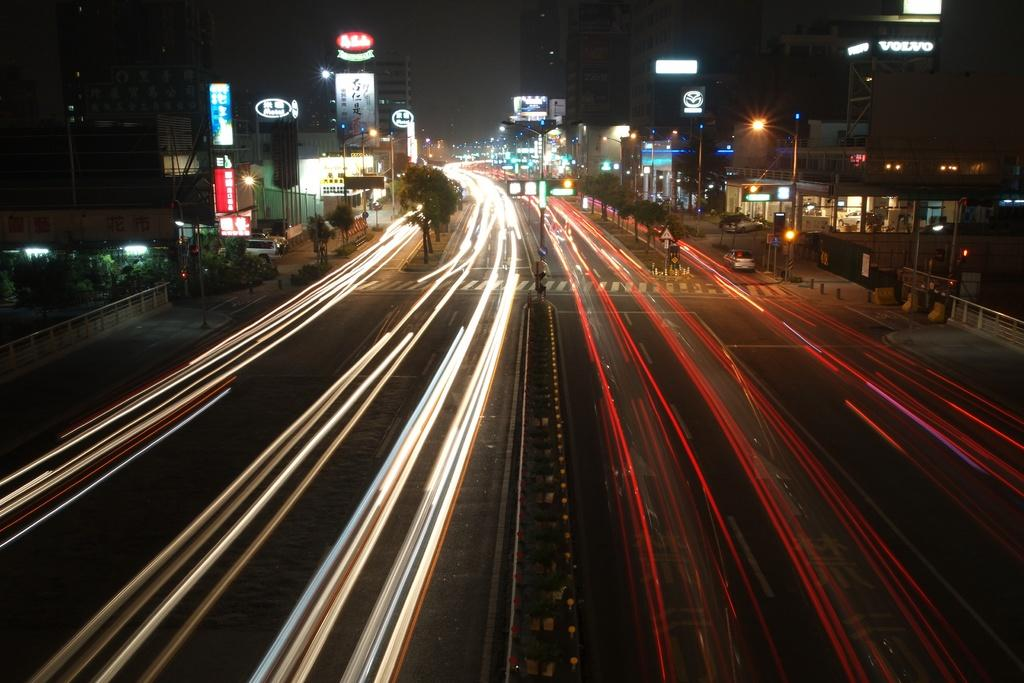What is the main feature in the center of the image? There is a road with lights in the center of the image. What can be seen in the background of the image? Buildings, trees, poles, lights, sign boards, at least one vehicle, fences, and a few other objects are visible in the background. Can you describe the lighting conditions in the image? Lights are present in the background, and there are lights on the road in the center of the image. What type of structures are visible in the background? Buildings and fences are visible in the background. What type of marble is used to decorate the feast in the image? There is no feast or marble present in the image. How many locks are visible on the vehicles in the image? There is no information about vehicles or locks in the image. 